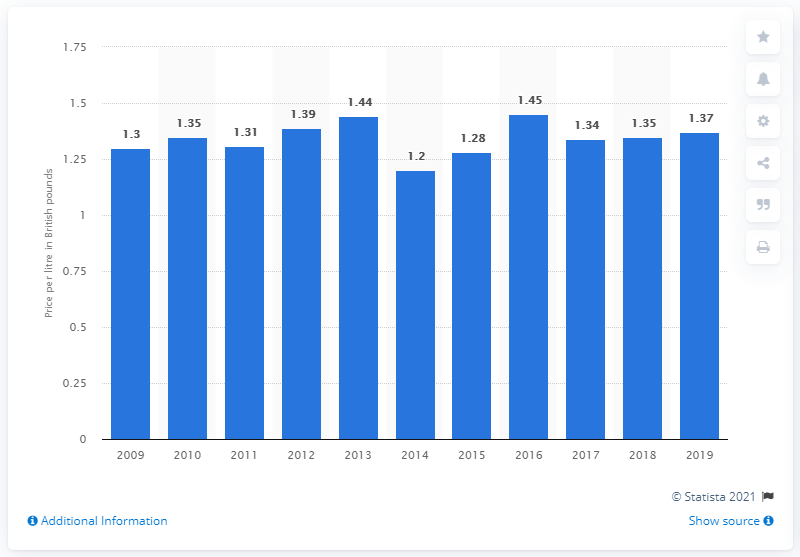Identify some key points in this picture. In 2009, the price of ice cream increased to 1.37 British pounds per liter. 